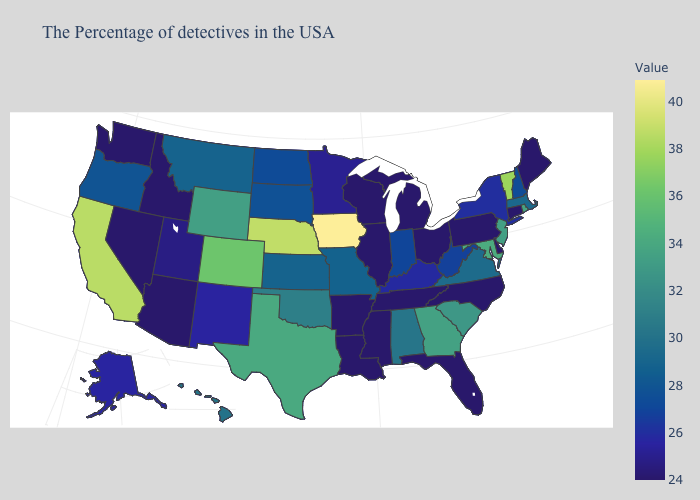Does South Carolina have a lower value than Nebraska?
Be succinct. Yes. Which states hav the highest value in the Northeast?
Be succinct. Vermont. Which states have the highest value in the USA?
Short answer required. Iowa. 